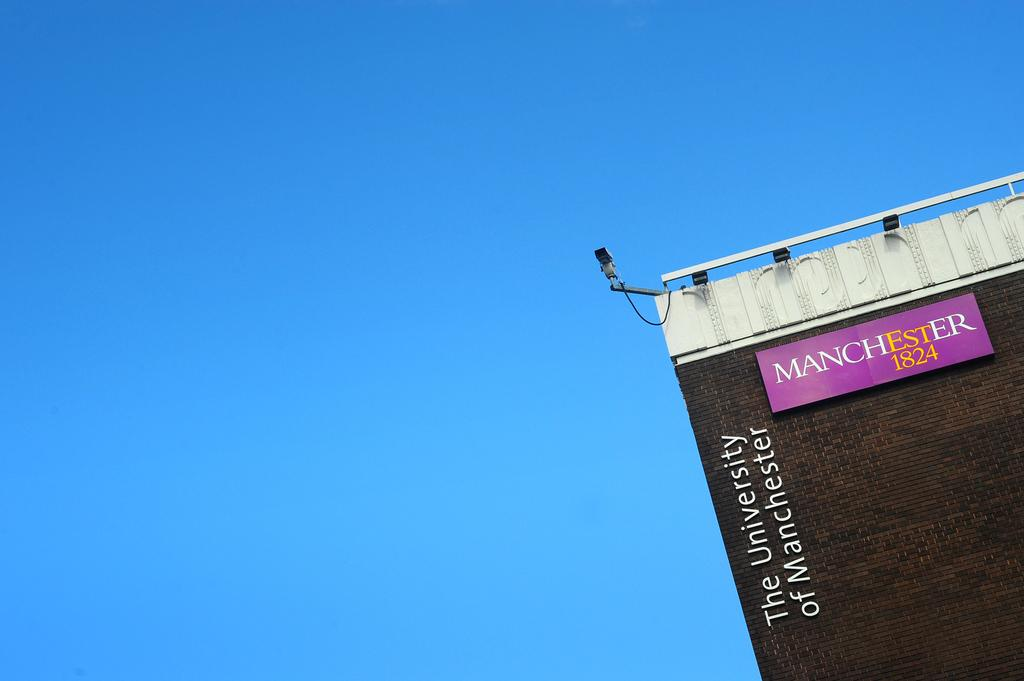<image>
Share a concise interpretation of the image provided. Manchester 1824 The University of Manchester logo on a building. 